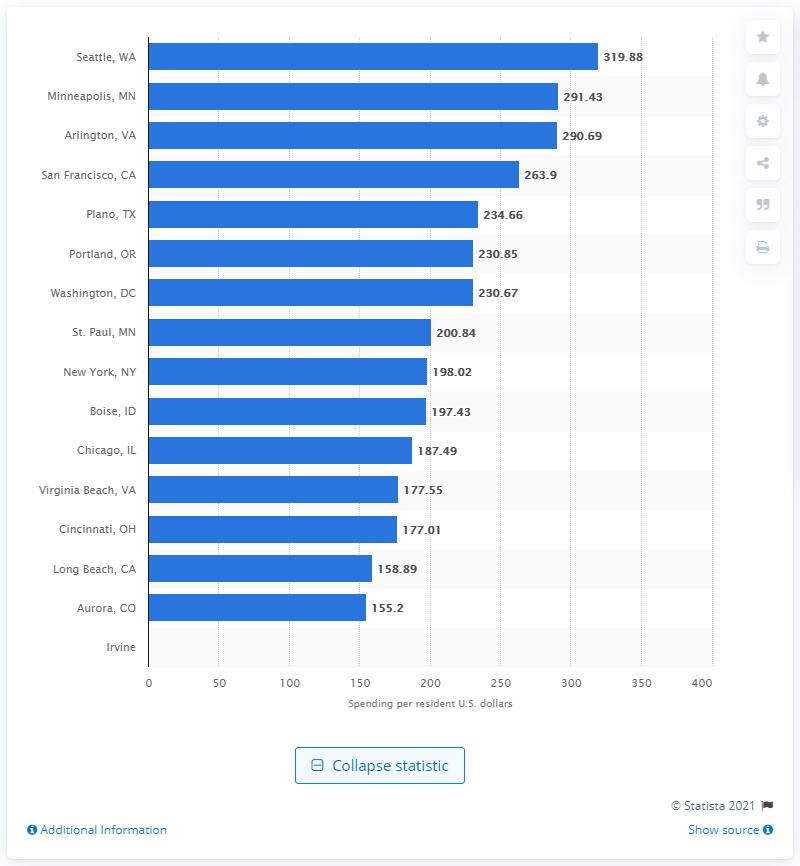Outline some significant characteristics in this image. In 2019, the city of Seattle spent an average of $319.88 per resident on parks and recreation. 